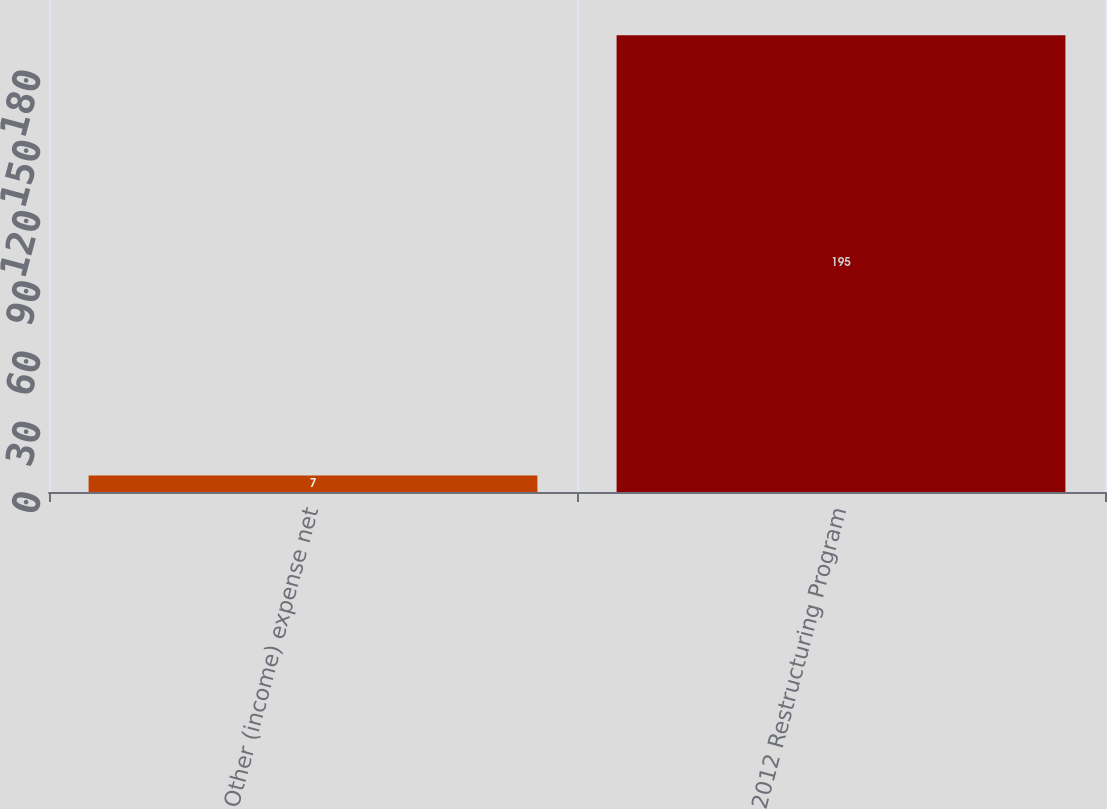Convert chart to OTSL. <chart><loc_0><loc_0><loc_500><loc_500><bar_chart><fcel>Other (income) expense net<fcel>2012 Restructuring Program<nl><fcel>7<fcel>195<nl></chart> 